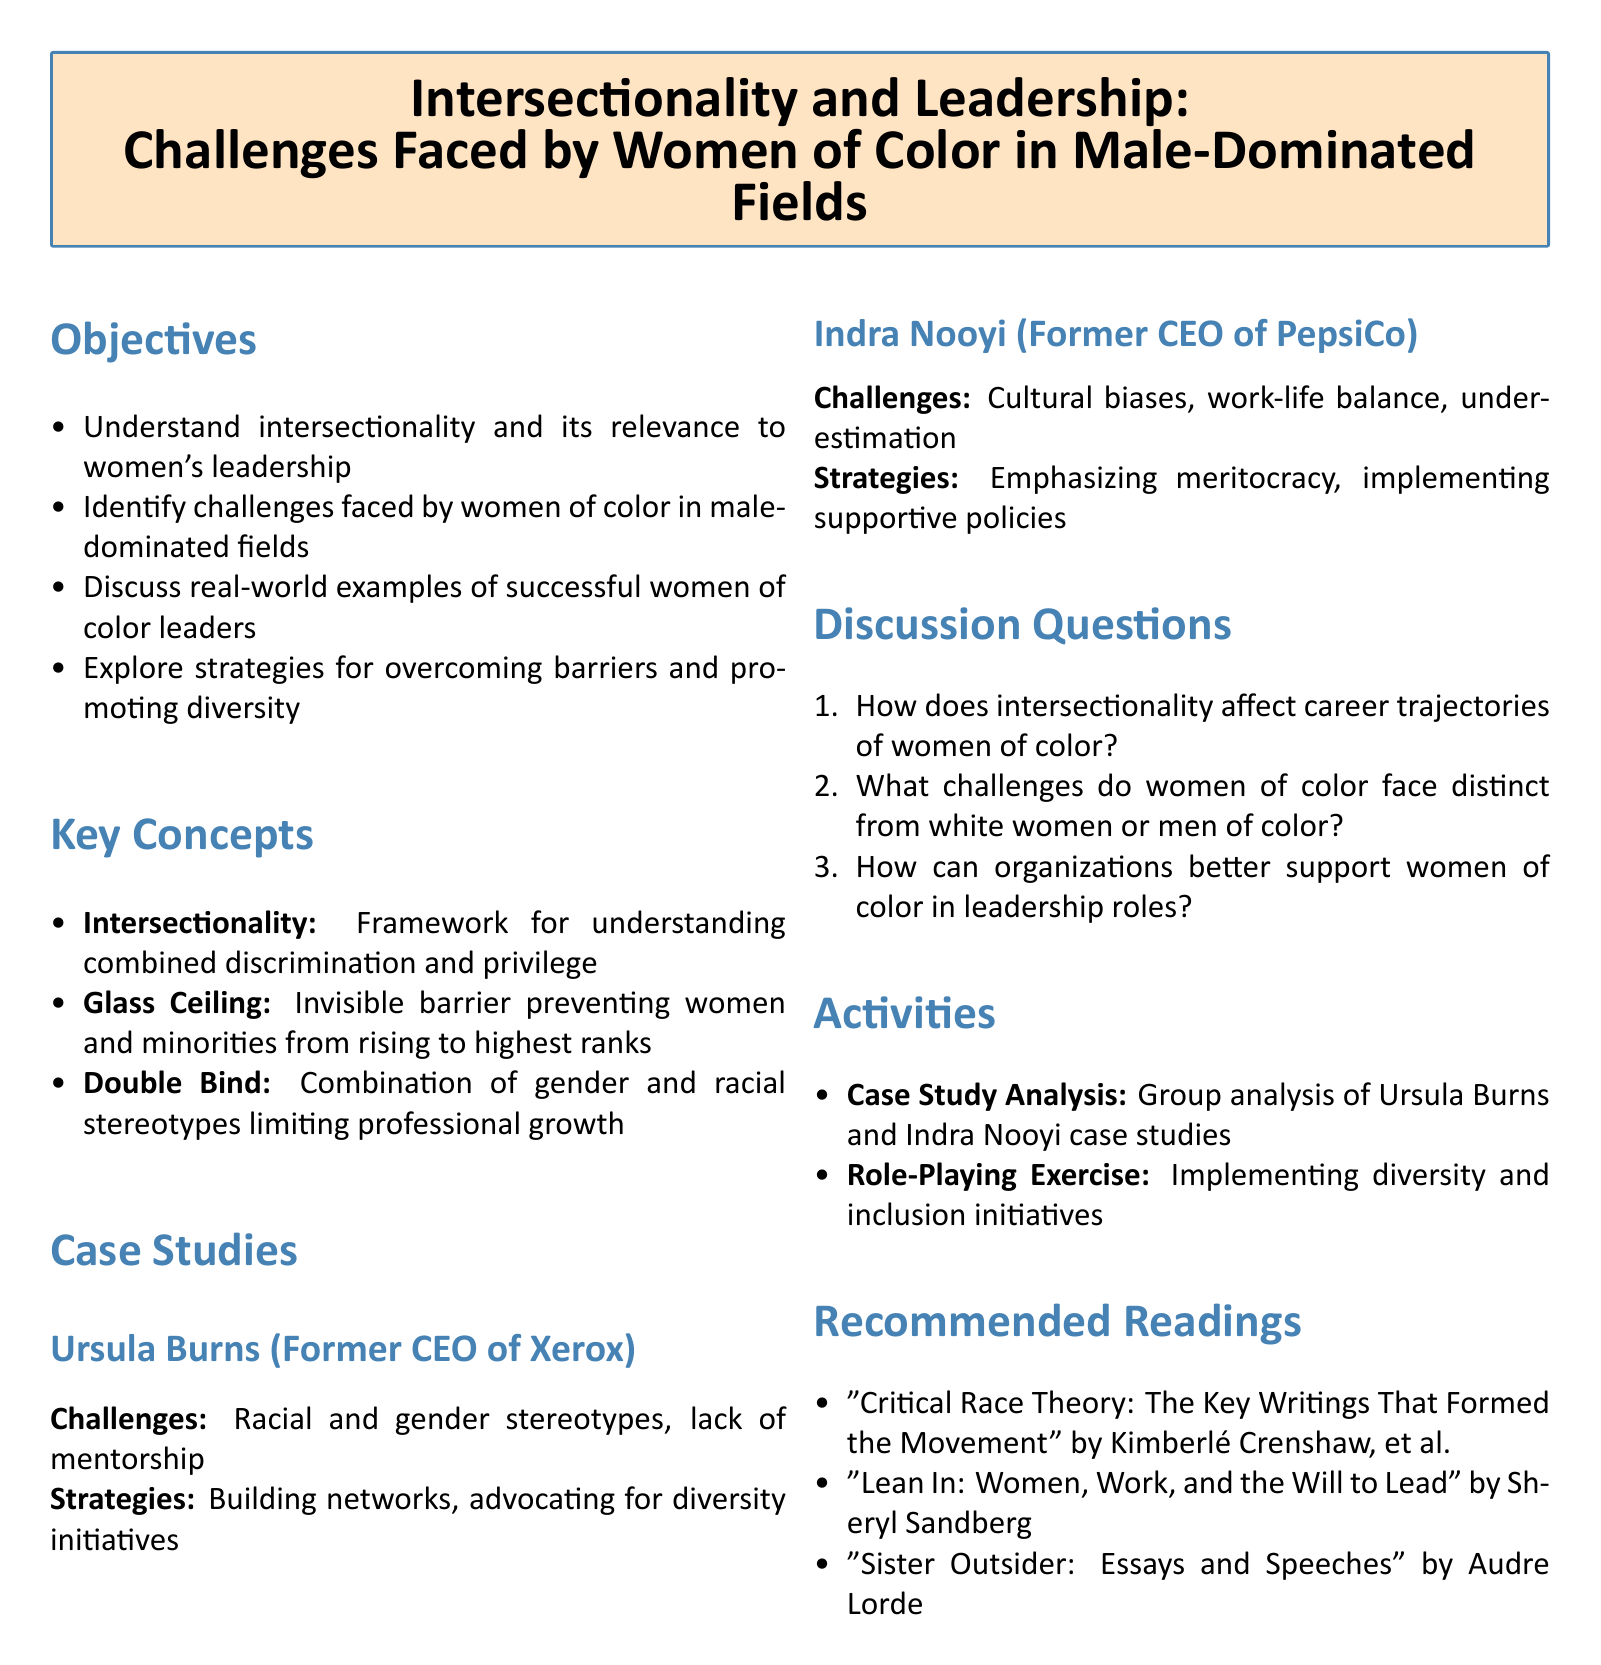What is the title of the lesson plan? The title of the lesson plan is provided in the tcolorbox at the beginning of the document.
Answer: Intersectionality and Leadership: Challenges Faced by Women of Color in Male-Dominated Fields Who is one of the leaders discussed in the case studies? The document lists specific leaders in the case studies.
Answer: Ursula Burns What is one key concept related to the challenges faced by women of color? The document outlines key concepts relevant to the discussion.
Answer: Glass Ceiling What is one challenge faced by Indra Nooyi? The challenges faced by the leaders are listed under each case study.
Answer: Cultural biases How many discussion questions are included in the document? The number of discussion questions is indicated by the enumeration in the section.
Answer: Three What type of exercise is included in the activities section? The activities section specifies types of exercises meant to engage students.
Answer: Role-Playing Exercise What is the focus of the first objective listed in the lesson plan? The objectives outline what will be understood or accomplished.
Answer: Understand intersectionality and its relevance to women's leadership Name a recommended reading included in the lesson plan. The document mentions specific readings relevant to the topic.
Answer: "Critical Race Theory: The Key Writings That Formed the Movement" by Kimberlé Crenshaw, et al What does the double bind refer to in the document? The document defines terms related to barriers faced by women of color.
Answer: Combination of gender and racial stereotypes limiting professional growth 